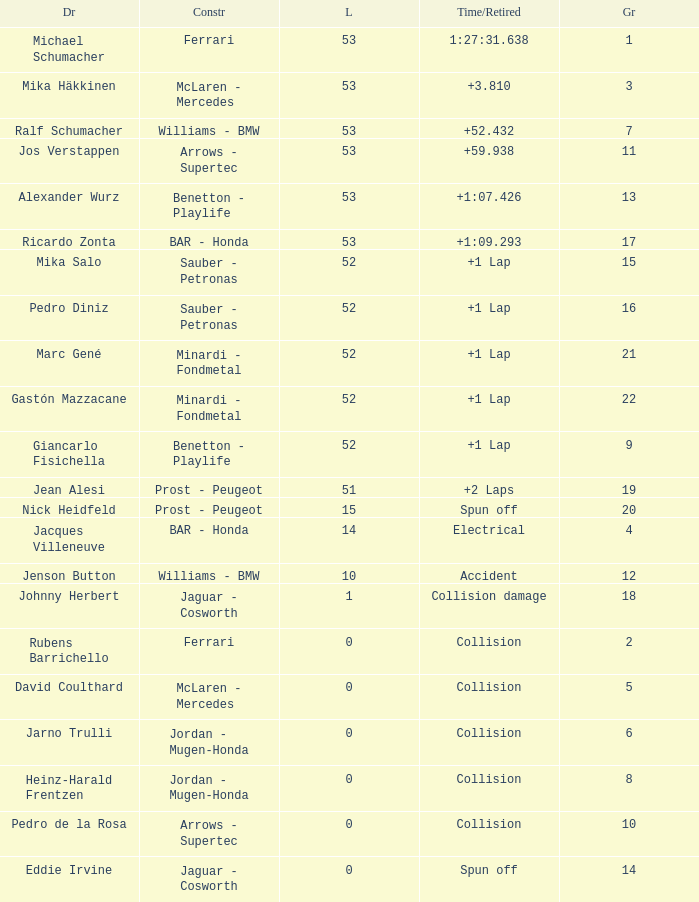How many laps did Ricardo Zonta have? 53.0. Could you parse the entire table as a dict? {'header': ['Dr', 'Constr', 'L', 'Time/Retired', 'Gr'], 'rows': [['Michael Schumacher', 'Ferrari', '53', '1:27:31.638', '1'], ['Mika Häkkinen', 'McLaren - Mercedes', '53', '+3.810', '3'], ['Ralf Schumacher', 'Williams - BMW', '53', '+52.432', '7'], ['Jos Verstappen', 'Arrows - Supertec', '53', '+59.938', '11'], ['Alexander Wurz', 'Benetton - Playlife', '53', '+1:07.426', '13'], ['Ricardo Zonta', 'BAR - Honda', '53', '+1:09.293', '17'], ['Mika Salo', 'Sauber - Petronas', '52', '+1 Lap', '15'], ['Pedro Diniz', 'Sauber - Petronas', '52', '+1 Lap', '16'], ['Marc Gené', 'Minardi - Fondmetal', '52', '+1 Lap', '21'], ['Gastón Mazzacane', 'Minardi - Fondmetal', '52', '+1 Lap', '22'], ['Giancarlo Fisichella', 'Benetton - Playlife', '52', '+1 Lap', '9'], ['Jean Alesi', 'Prost - Peugeot', '51', '+2 Laps', '19'], ['Nick Heidfeld', 'Prost - Peugeot', '15', 'Spun off', '20'], ['Jacques Villeneuve', 'BAR - Honda', '14', 'Electrical', '4'], ['Jenson Button', 'Williams - BMW', '10', 'Accident', '12'], ['Johnny Herbert', 'Jaguar - Cosworth', '1', 'Collision damage', '18'], ['Rubens Barrichello', 'Ferrari', '0', 'Collision', '2'], ['David Coulthard', 'McLaren - Mercedes', '0', 'Collision', '5'], ['Jarno Trulli', 'Jordan - Mugen-Honda', '0', 'Collision', '6'], ['Heinz-Harald Frentzen', 'Jordan - Mugen-Honda', '0', 'Collision', '8'], ['Pedro de la Rosa', 'Arrows - Supertec', '0', 'Collision', '10'], ['Eddie Irvine', 'Jaguar - Cosworth', '0', 'Spun off', '14']]} 